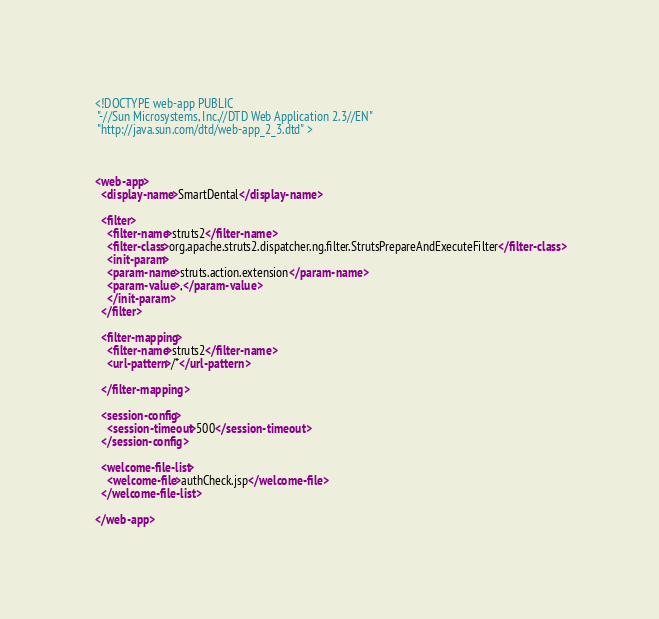<code> <loc_0><loc_0><loc_500><loc_500><_XML_><!DOCTYPE web-app PUBLIC
 "-//Sun Microsystems, Inc.//DTD Web Application 2.3//EN"
 "http://java.sun.com/dtd/web-app_2_3.dtd" >
  
  

<web-app>
  <display-name>SmartDental</display-name>
  
  <filter>
  	<filter-name>struts2</filter-name>
  	<filter-class>org.apache.struts2.dispatcher.ng.filter.StrutsPrepareAndExecuteFilter</filter-class>
  	<init-param>
  	<param-name>struts.action.extension</param-name>
  	<param-value>,</param-value>
  	</init-param>
  </filter>
 
  <filter-mapping>
	<filter-name>struts2</filter-name>
	<url-pattern>/*</url-pattern>
	
  </filter-mapping>
  
  <session-config>  
    <session-timeout>500</session-timeout>  
  </session-config>
    
  <welcome-file-list>
    <welcome-file>authCheck.jsp</welcome-file>
  </welcome-file-list>

</web-app>
</code> 